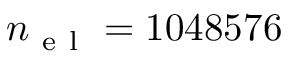<formula> <loc_0><loc_0><loc_500><loc_500>n _ { e l } = 1 0 4 8 5 7 6</formula> 